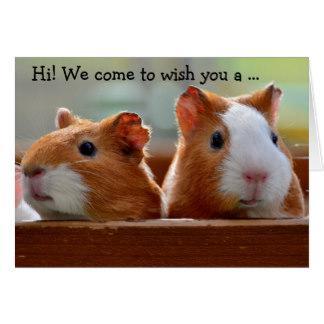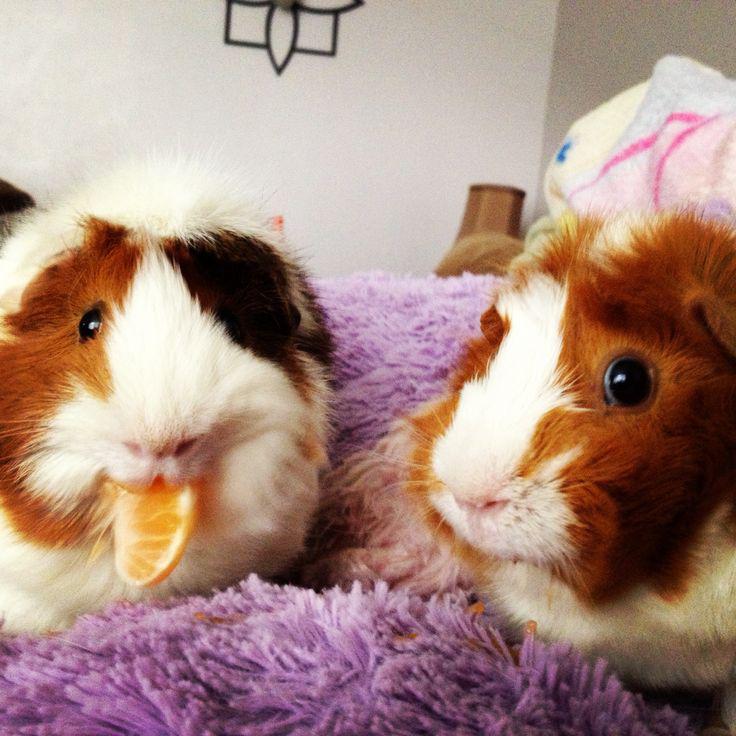The first image is the image on the left, the second image is the image on the right. Given the left and right images, does the statement "There is at least one guinea pig with food in its mouth" hold true? Answer yes or no. Yes. 